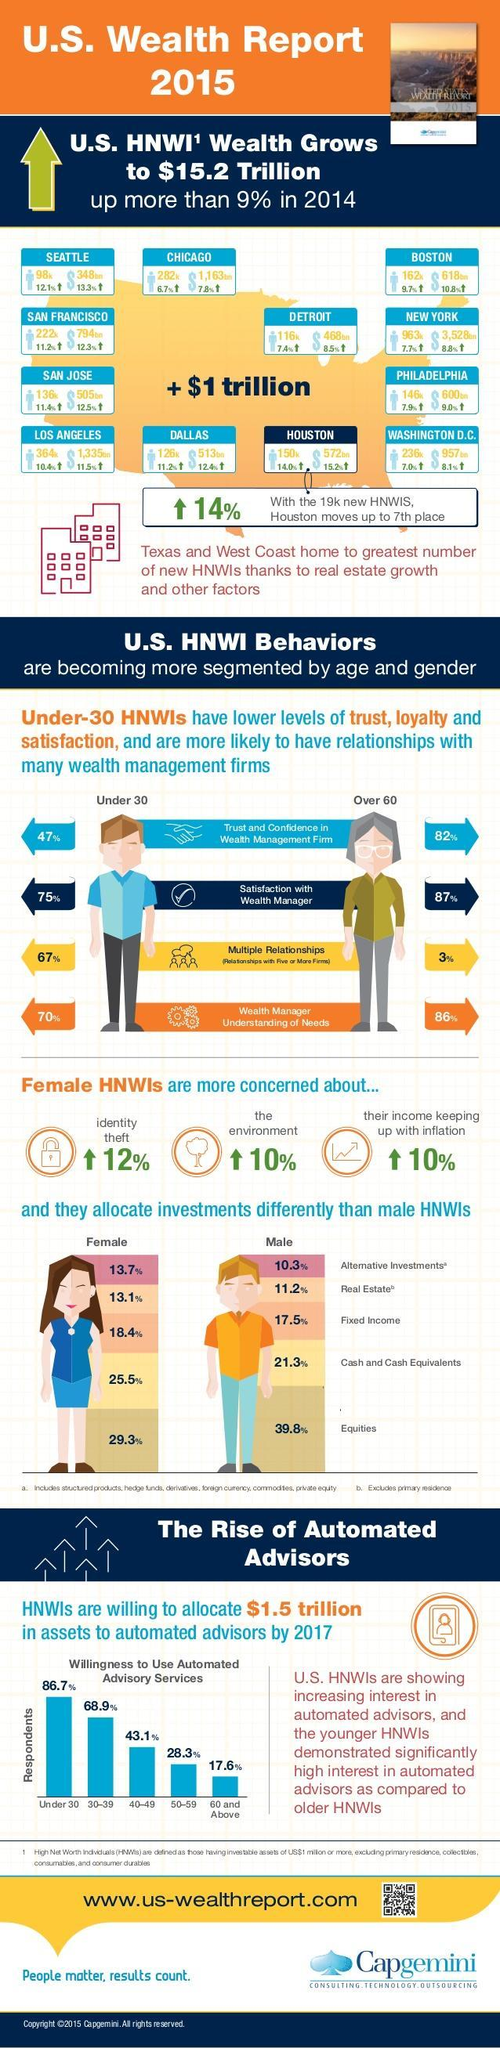Which age group is less likely to have relationships with multiple wealth management firms?
Answer the question with a short phrase. Over 60 What percentage female HNWIs invest in Real Estate? 13.1 What is the increase in percentage of female HNWIs who show concern about environment? 10% HNWIs of which gender invest more in equities? Male Which age group shows more trust and confidence in wealth management firm? Over 60 